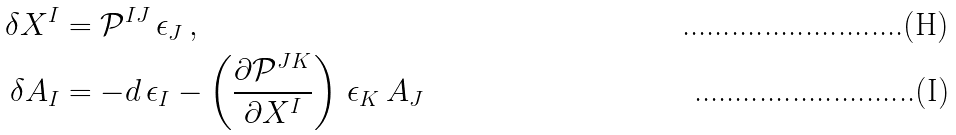<formula> <loc_0><loc_0><loc_500><loc_500>\delta X ^ { I } & = \mathcal { P } ^ { I J } \, \epsilon _ { J } \, , \\ \delta A _ { I } & = - d \, \epsilon _ { I } - \left ( \frac { \partial \mathcal { P } ^ { J K } } { \partial X ^ { I } } \right ) \, \epsilon _ { K } \, A _ { J }</formula> 